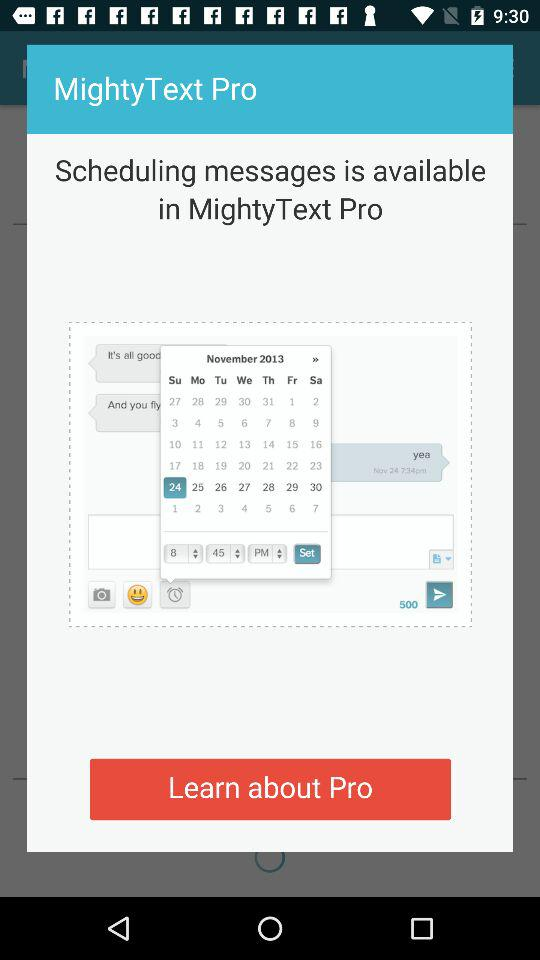What is the application name? The application name is "MightyText Pro". 